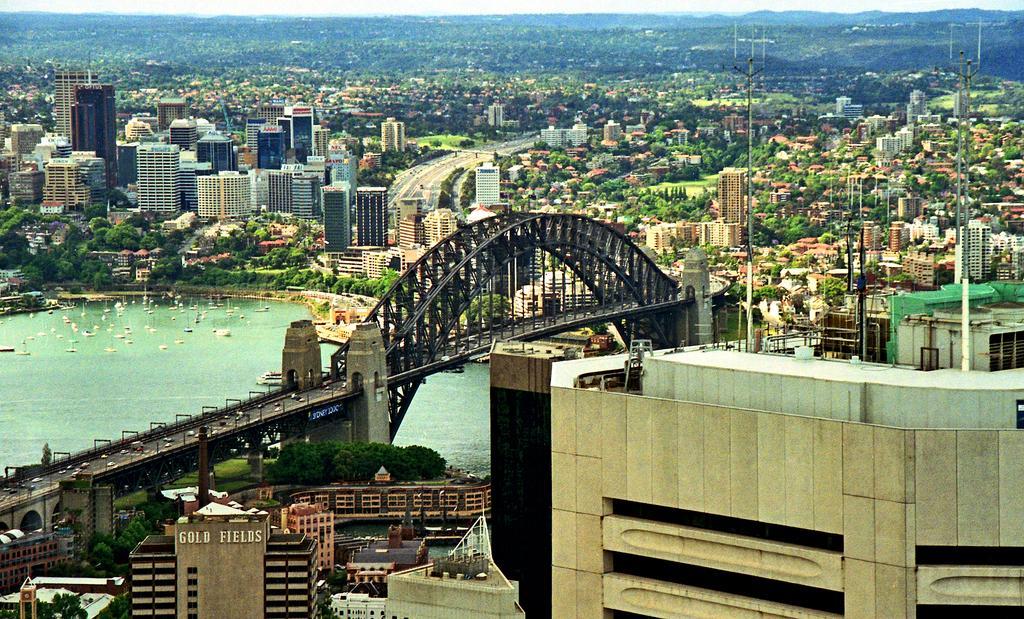In one or two sentences, can you explain what this image depicts? In this picture we can see buildings, trees, bridgewater, vehicles and poles. 